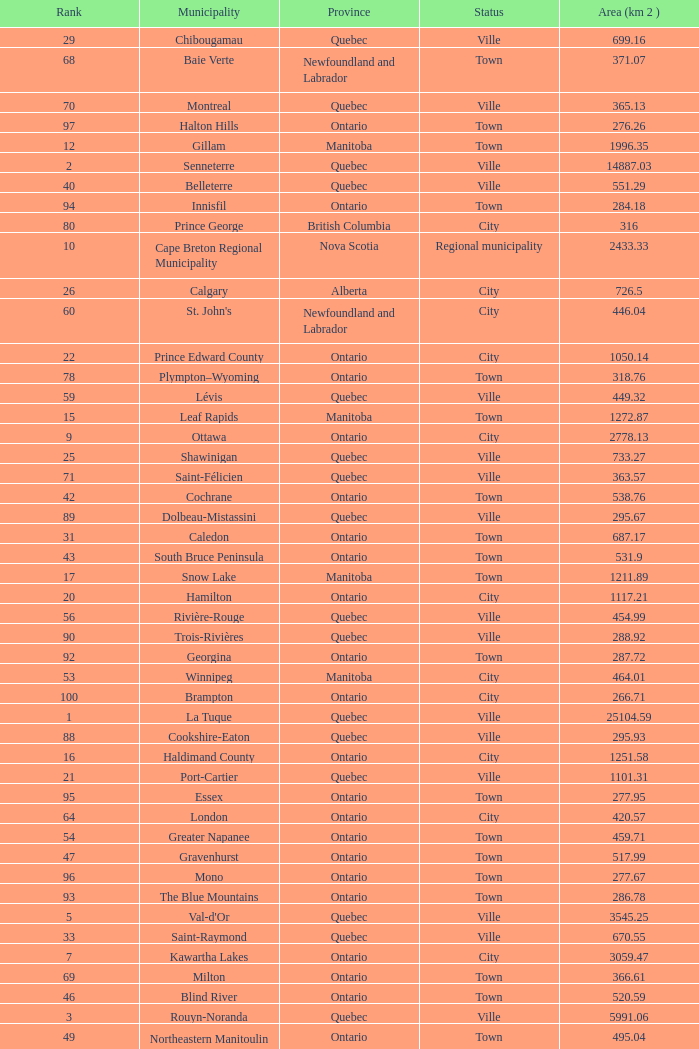What's the total of Rank that has an Area (KM 2) of 1050.14? 22.0. Can you parse all the data within this table? {'header': ['Rank', 'Municipality', 'Province', 'Status', 'Area (km 2 )'], 'rows': [['29', 'Chibougamau', 'Quebec', 'Ville', '699.16'], ['68', 'Baie Verte', 'Newfoundland and Labrador', 'Town', '371.07'], ['70', 'Montreal', 'Quebec', 'Ville', '365.13'], ['97', 'Halton Hills', 'Ontario', 'Town', '276.26'], ['12', 'Gillam', 'Manitoba', 'Town', '1996.35'], ['2', 'Senneterre', 'Quebec', 'Ville', '14887.03'], ['40', 'Belleterre', 'Quebec', 'Ville', '551.29'], ['94', 'Innisfil', 'Ontario', 'Town', '284.18'], ['80', 'Prince George', 'British Columbia', 'City', '316'], ['10', 'Cape Breton Regional Municipality', 'Nova Scotia', 'Regional municipality', '2433.33'], ['26', 'Calgary', 'Alberta', 'City', '726.5'], ['60', "St. John's", 'Newfoundland and Labrador', 'City', '446.04'], ['22', 'Prince Edward County', 'Ontario', 'City', '1050.14'], ['78', 'Plympton–Wyoming', 'Ontario', 'Town', '318.76'], ['59', 'Lévis', 'Quebec', 'Ville', '449.32'], ['15', 'Leaf Rapids', 'Manitoba', 'Town', '1272.87'], ['9', 'Ottawa', 'Ontario', 'City', '2778.13'], ['25', 'Shawinigan', 'Quebec', 'Ville', '733.27'], ['71', 'Saint-Félicien', 'Quebec', 'Ville', '363.57'], ['42', 'Cochrane', 'Ontario', 'Town', '538.76'], ['89', 'Dolbeau-Mistassini', 'Quebec', 'Ville', '295.67'], ['31', 'Caledon', 'Ontario', 'Town', '687.17'], ['43', 'South Bruce Peninsula', 'Ontario', 'Town', '531.9'], ['17', 'Snow Lake', 'Manitoba', 'Town', '1211.89'], ['20', 'Hamilton', 'Ontario', 'City', '1117.21'], ['56', 'Rivière-Rouge', 'Quebec', 'Ville', '454.99'], ['90', 'Trois-Rivières', 'Quebec', 'Ville', '288.92'], ['92', 'Georgina', 'Ontario', 'Town', '287.72'], ['53', 'Winnipeg', 'Manitoba', 'City', '464.01'], ['100', 'Brampton', 'Ontario', 'City', '266.71'], ['1', 'La Tuque', 'Quebec', 'Ville', '25104.59'], ['88', 'Cookshire-Eaton', 'Quebec', 'Ville', '295.93'], ['16', 'Haldimand County', 'Ontario', 'City', '1251.58'], ['21', 'Port-Cartier', 'Quebec', 'Ville', '1101.31'], ['95', 'Essex', 'Ontario', 'Town', '277.95'], ['64', 'London', 'Ontario', 'City', '420.57'], ['54', 'Greater Napanee', 'Ontario', 'Town', '459.71'], ['47', 'Gravenhurst', 'Ontario', 'Town', '517.99'], ['96', 'Mono', 'Ontario', 'Town', '277.67'], ['93', 'The Blue Mountains', 'Ontario', 'Town', '286.78'], ['5', "Val-d'Or", 'Quebec', 'Ville', '3545.25'], ['33', 'Saint-Raymond', 'Quebec', 'Ville', '670.55'], ['7', 'Kawartha Lakes', 'Ontario', 'City', '3059.47'], ['69', 'Milton', 'Ontario', 'Town', '366.61'], ['46', 'Blind River', 'Ontario', 'Town', '520.59'], ['3', 'Rouyn-Noranda', 'Quebec', 'Ville', '5991.06'], ['49', 'Northeastern Manitoulin and the Islands', 'Ontario', 'Town', '495.04'], ['32', 'Edmonton', 'Alberta', 'City', '684.37'], ['79', 'Surrey', 'British Columbia', 'City', '317.19'], ['91', 'Mississauga', 'Ontario', 'City', '288.53'], ['14', 'Norfolk County', 'Ontario', 'City', '1606.91'], ['98', 'New Tecumseth', 'Ontario', 'Town', '274.18'], ['34', 'Laurentian Hills', 'Ontario', 'Town', '640.37'], ['66', 'Whitehorse', 'Yukon', 'City', '416.43'], ['8', 'Timmins', 'Ontario', 'City', '2961.58'], ['76', 'Baie-Comeau', 'Quebec', 'Ville', '338.88'], ['86', 'Erin', 'Ontario', 'Town', '296.98'], ['41', 'Baie-Saint-Paul', 'Quebec', 'Ville', '546.27'], ['99', 'Vaughan', 'Ontario', 'City', '273.58'], ['45', 'Kearney', 'Ontario', 'Town', '529.5'], ['35', 'Toronto', 'Ontario', 'City', '630.18'], ['84', 'Minto', 'Ontario', 'Town', '300.37'], ['72', 'Abbotsford', 'British Columbia', 'City', '359.36'], ['63', 'Amos', 'Quebec', 'Ville', '430.06'], ['82', 'North Bay', 'Ontario', 'City', '314.91'], ['51', 'Mirabel', 'Quebec', 'Ville', '485.51'], ['4', 'Halifax Regional Municipality', 'Nova Scotia', 'Regional municipality', '5490.18'], ['75', 'Pohénégamook', 'Quebec', 'Ville', '340.33'], ['37', 'Iroquois Falls', 'Ontario', 'Town', '599.43'], ['81', 'Saint John', 'New Brunswick', 'City', '315.49'], ['74', 'Gatineau', 'Quebec', 'Ville', '342.32'], ['18', 'Saguenay', 'Quebec', 'Ville', '1126.27'], ['67', 'Gracefield', 'Quebec', 'Ville', '386.21'], ['65', 'Chandler', 'Quebec', 'Ville', '419.5'], ['55', 'La Malbaie', 'Quebec', 'Ville', '459.34'], ['30', 'Elliot Lake', 'Ontario', 'City', '698.12'], ['58', 'Kingston', 'Ontario', 'City', '450.39'], ['77', 'Thunder Bay', 'Ontario', 'City', '328.48'], ['23', 'Lynn Lake', 'Manitoba', 'Town', '910.23'], ['87', 'Clarence-Rockland', 'Ontario', 'City', '296.53'], ['44', 'Lakeshore', 'Ontario', 'Town', '530.32'], ['11', 'Queens', 'Nova Scotia', 'Regional municipality', '2386.58'], ['36', 'Bracebridge', 'Ontario', 'Town', '617.42'], ['85', 'Kamloops', 'British Columbia', 'City', '297.3'], ['13', 'Sept-Îles', 'Quebec', 'Ville', '1764.26'], ['61', 'Bécancour', 'Quebec', 'Ville', '441'], ['19', 'Gaspé', 'Quebec', 'Ville', '1120.62'], ['50', 'Quinte West', 'Ontario', 'City', '493.85'], ['24', 'County of Brant', 'Ontario', 'City', '843.1'], ['62', 'Percé', 'Quebec', 'Ville', '432.39'], ['73', 'Sherbrooke', 'Quebec', 'Ville', '353.46'], ['39', 'Dégelis', 'Quebec', 'Ville', '556.64'], ['52', 'Fermont', 'Quebec', 'Ville', '470.67'], ['57', 'Québec City', 'Quebec', 'Ville', '454.26'], ['38', 'Mont-Laurier', 'Quebec', 'Ville', '590.35'], ['27', 'Témiscaming', 'Quebec', 'Ville', '717.87'], ['48', 'Mississippi Mills', 'Ontario', 'Town', '509.05'], ['6', 'Greater Sudbury', 'Ontario', 'City', '3200.56'], ['28', 'Huntsville', 'Ontario', 'Town', '703.23'], ['83', 'Happy Valley-Goose Bay', 'Newfoundland and Labrador', 'Town', '305.85']]} 